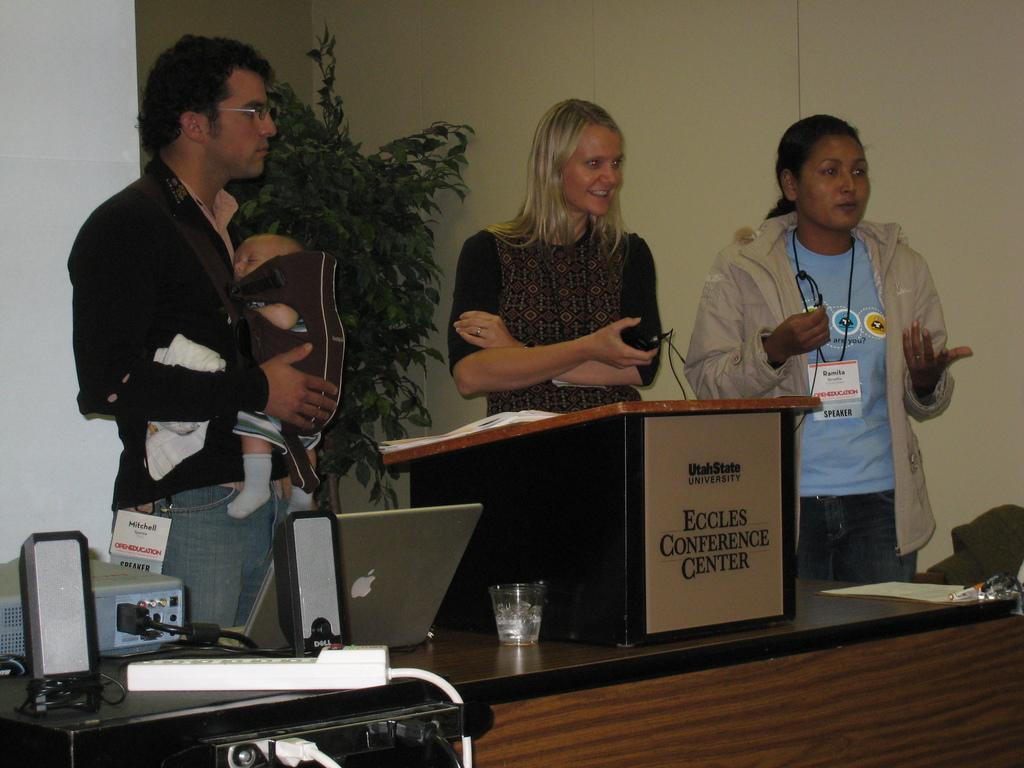Describe this image in one or two sentences. In the image we can see there are three people who are standing and on table there is laptop, glass, projector and switch board. 